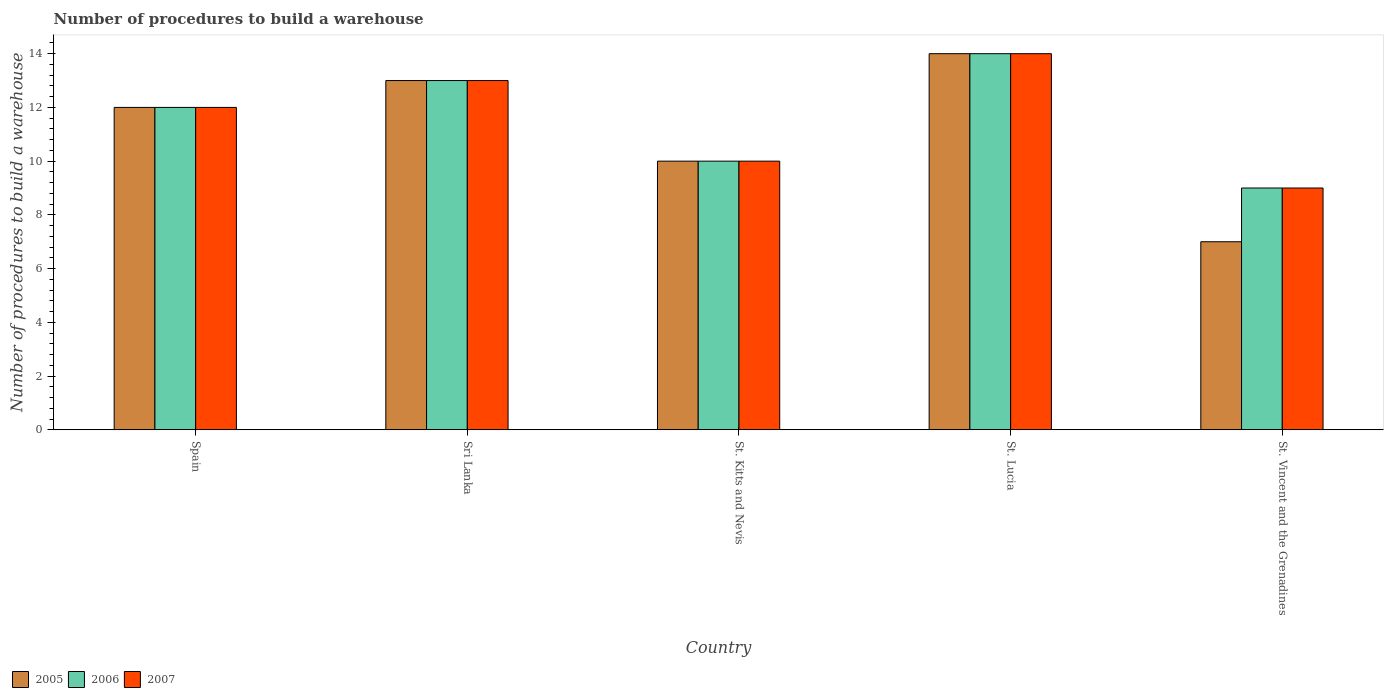How many different coloured bars are there?
Your answer should be compact. 3. Are the number of bars on each tick of the X-axis equal?
Give a very brief answer. Yes. How many bars are there on the 2nd tick from the left?
Offer a very short reply. 3. How many bars are there on the 4th tick from the right?
Make the answer very short. 3. What is the label of the 4th group of bars from the left?
Ensure brevity in your answer.  St. Lucia. In how many cases, is the number of bars for a given country not equal to the number of legend labels?
Ensure brevity in your answer.  0. Across all countries, what is the maximum number of procedures to build a warehouse in in 2006?
Your answer should be very brief. 14. In which country was the number of procedures to build a warehouse in in 2007 maximum?
Provide a succinct answer. St. Lucia. In which country was the number of procedures to build a warehouse in in 2005 minimum?
Provide a succinct answer. St. Vincent and the Grenadines. What is the total number of procedures to build a warehouse in in 2006 in the graph?
Give a very brief answer. 58. What is the difference between the number of procedures to build a warehouse in of/in 2006 and number of procedures to build a warehouse in of/in 2005 in Spain?
Keep it short and to the point. 0. What is the ratio of the number of procedures to build a warehouse in in 2007 in St. Kitts and Nevis to that in St. Lucia?
Offer a very short reply. 0.71. Is the number of procedures to build a warehouse in in 2006 in Spain less than that in Sri Lanka?
Provide a succinct answer. Yes. Is the difference between the number of procedures to build a warehouse in in 2006 in Spain and Sri Lanka greater than the difference between the number of procedures to build a warehouse in in 2005 in Spain and Sri Lanka?
Provide a succinct answer. No. In how many countries, is the number of procedures to build a warehouse in in 2007 greater than the average number of procedures to build a warehouse in in 2007 taken over all countries?
Provide a short and direct response. 3. Is it the case that in every country, the sum of the number of procedures to build a warehouse in in 2005 and number of procedures to build a warehouse in in 2006 is greater than the number of procedures to build a warehouse in in 2007?
Give a very brief answer. Yes. How many bars are there?
Offer a terse response. 15. Are all the bars in the graph horizontal?
Keep it short and to the point. No. How many countries are there in the graph?
Give a very brief answer. 5. Are the values on the major ticks of Y-axis written in scientific E-notation?
Your answer should be compact. No. Where does the legend appear in the graph?
Keep it short and to the point. Bottom left. How are the legend labels stacked?
Ensure brevity in your answer.  Horizontal. What is the title of the graph?
Your response must be concise. Number of procedures to build a warehouse. What is the label or title of the Y-axis?
Keep it short and to the point. Number of procedures to build a warehouse. What is the Number of procedures to build a warehouse in 2007 in Spain?
Give a very brief answer. 12. What is the Number of procedures to build a warehouse of 2005 in Sri Lanka?
Keep it short and to the point. 13. What is the Number of procedures to build a warehouse of 2006 in Sri Lanka?
Provide a succinct answer. 13. What is the Number of procedures to build a warehouse in 2005 in St. Kitts and Nevis?
Provide a succinct answer. 10. What is the Number of procedures to build a warehouse in 2007 in St. Kitts and Nevis?
Make the answer very short. 10. What is the Number of procedures to build a warehouse in 2005 in St. Vincent and the Grenadines?
Make the answer very short. 7. Across all countries, what is the maximum Number of procedures to build a warehouse of 2007?
Your answer should be very brief. 14. Across all countries, what is the minimum Number of procedures to build a warehouse in 2007?
Your answer should be compact. 9. What is the difference between the Number of procedures to build a warehouse of 2005 in Spain and that in Sri Lanka?
Your answer should be very brief. -1. What is the difference between the Number of procedures to build a warehouse of 2007 in Spain and that in Sri Lanka?
Give a very brief answer. -1. What is the difference between the Number of procedures to build a warehouse of 2005 in Spain and that in St. Kitts and Nevis?
Ensure brevity in your answer.  2. What is the difference between the Number of procedures to build a warehouse of 2005 in Spain and that in St. Lucia?
Make the answer very short. -2. What is the difference between the Number of procedures to build a warehouse of 2007 in Spain and that in St. Lucia?
Provide a succinct answer. -2. What is the difference between the Number of procedures to build a warehouse of 2005 in Spain and that in St. Vincent and the Grenadines?
Ensure brevity in your answer.  5. What is the difference between the Number of procedures to build a warehouse in 2006 in Spain and that in St. Vincent and the Grenadines?
Offer a very short reply. 3. What is the difference between the Number of procedures to build a warehouse of 2007 in Spain and that in St. Vincent and the Grenadines?
Provide a short and direct response. 3. What is the difference between the Number of procedures to build a warehouse in 2005 in Sri Lanka and that in St. Vincent and the Grenadines?
Ensure brevity in your answer.  6. What is the difference between the Number of procedures to build a warehouse of 2006 in Sri Lanka and that in St. Vincent and the Grenadines?
Your answer should be very brief. 4. What is the difference between the Number of procedures to build a warehouse of 2007 in Sri Lanka and that in St. Vincent and the Grenadines?
Keep it short and to the point. 4. What is the difference between the Number of procedures to build a warehouse in 2005 in St. Kitts and Nevis and that in St. Lucia?
Your answer should be compact. -4. What is the difference between the Number of procedures to build a warehouse in 2006 in St. Kitts and Nevis and that in St. Lucia?
Make the answer very short. -4. What is the difference between the Number of procedures to build a warehouse of 2005 in St. Kitts and Nevis and that in St. Vincent and the Grenadines?
Make the answer very short. 3. What is the difference between the Number of procedures to build a warehouse of 2006 in St. Kitts and Nevis and that in St. Vincent and the Grenadines?
Your response must be concise. 1. What is the difference between the Number of procedures to build a warehouse in 2007 in St. Kitts and Nevis and that in St. Vincent and the Grenadines?
Keep it short and to the point. 1. What is the difference between the Number of procedures to build a warehouse in 2006 in St. Lucia and that in St. Vincent and the Grenadines?
Give a very brief answer. 5. What is the difference between the Number of procedures to build a warehouse of 2005 in Spain and the Number of procedures to build a warehouse of 2006 in Sri Lanka?
Give a very brief answer. -1. What is the difference between the Number of procedures to build a warehouse of 2005 in Spain and the Number of procedures to build a warehouse of 2006 in St. Kitts and Nevis?
Keep it short and to the point. 2. What is the difference between the Number of procedures to build a warehouse in 2006 in Spain and the Number of procedures to build a warehouse in 2007 in St. Kitts and Nevis?
Keep it short and to the point. 2. What is the difference between the Number of procedures to build a warehouse in 2005 in Spain and the Number of procedures to build a warehouse in 2006 in St. Vincent and the Grenadines?
Ensure brevity in your answer.  3. What is the difference between the Number of procedures to build a warehouse in 2005 in Spain and the Number of procedures to build a warehouse in 2007 in St. Vincent and the Grenadines?
Your response must be concise. 3. What is the difference between the Number of procedures to build a warehouse of 2006 in Sri Lanka and the Number of procedures to build a warehouse of 2007 in St. Kitts and Nevis?
Ensure brevity in your answer.  3. What is the difference between the Number of procedures to build a warehouse of 2006 in Sri Lanka and the Number of procedures to build a warehouse of 2007 in St. Lucia?
Give a very brief answer. -1. What is the difference between the Number of procedures to build a warehouse in 2005 in Sri Lanka and the Number of procedures to build a warehouse in 2007 in St. Vincent and the Grenadines?
Your answer should be compact. 4. What is the difference between the Number of procedures to build a warehouse of 2005 in St. Kitts and Nevis and the Number of procedures to build a warehouse of 2006 in St. Lucia?
Your response must be concise. -4. What is the difference between the Number of procedures to build a warehouse in 2006 in St. Kitts and Nevis and the Number of procedures to build a warehouse in 2007 in St. Lucia?
Your response must be concise. -4. What is the difference between the Number of procedures to build a warehouse in 2006 in St. Kitts and Nevis and the Number of procedures to build a warehouse in 2007 in St. Vincent and the Grenadines?
Provide a succinct answer. 1. What is the difference between the Number of procedures to build a warehouse of 2005 in St. Lucia and the Number of procedures to build a warehouse of 2006 in St. Vincent and the Grenadines?
Make the answer very short. 5. What is the difference between the Number of procedures to build a warehouse of 2006 in St. Lucia and the Number of procedures to build a warehouse of 2007 in St. Vincent and the Grenadines?
Your response must be concise. 5. What is the average Number of procedures to build a warehouse in 2007 per country?
Your response must be concise. 11.6. What is the difference between the Number of procedures to build a warehouse of 2005 and Number of procedures to build a warehouse of 2006 in Spain?
Give a very brief answer. 0. What is the difference between the Number of procedures to build a warehouse in 2006 and Number of procedures to build a warehouse in 2007 in Spain?
Your answer should be compact. 0. What is the difference between the Number of procedures to build a warehouse of 2005 and Number of procedures to build a warehouse of 2006 in Sri Lanka?
Offer a very short reply. 0. What is the difference between the Number of procedures to build a warehouse of 2005 and Number of procedures to build a warehouse of 2007 in Sri Lanka?
Keep it short and to the point. 0. What is the difference between the Number of procedures to build a warehouse of 2006 and Number of procedures to build a warehouse of 2007 in Sri Lanka?
Your response must be concise. 0. What is the difference between the Number of procedures to build a warehouse in 2005 and Number of procedures to build a warehouse in 2006 in St. Lucia?
Offer a terse response. 0. What is the difference between the Number of procedures to build a warehouse in 2005 and Number of procedures to build a warehouse in 2007 in St. Lucia?
Keep it short and to the point. 0. What is the difference between the Number of procedures to build a warehouse of 2005 and Number of procedures to build a warehouse of 2006 in St. Vincent and the Grenadines?
Offer a very short reply. -2. What is the difference between the Number of procedures to build a warehouse in 2005 and Number of procedures to build a warehouse in 2007 in St. Vincent and the Grenadines?
Your response must be concise. -2. What is the ratio of the Number of procedures to build a warehouse of 2005 in Spain to that in Sri Lanka?
Provide a succinct answer. 0.92. What is the ratio of the Number of procedures to build a warehouse of 2006 in Spain to that in Sri Lanka?
Offer a terse response. 0.92. What is the ratio of the Number of procedures to build a warehouse of 2007 in Spain to that in Sri Lanka?
Keep it short and to the point. 0.92. What is the ratio of the Number of procedures to build a warehouse in 2005 in Spain to that in St. Kitts and Nevis?
Your response must be concise. 1.2. What is the ratio of the Number of procedures to build a warehouse in 2006 in Spain to that in St. Kitts and Nevis?
Offer a terse response. 1.2. What is the ratio of the Number of procedures to build a warehouse of 2006 in Spain to that in St. Lucia?
Offer a terse response. 0.86. What is the ratio of the Number of procedures to build a warehouse of 2005 in Spain to that in St. Vincent and the Grenadines?
Make the answer very short. 1.71. What is the ratio of the Number of procedures to build a warehouse in 2007 in Spain to that in St. Vincent and the Grenadines?
Give a very brief answer. 1.33. What is the ratio of the Number of procedures to build a warehouse of 2005 in Sri Lanka to that in St. Kitts and Nevis?
Keep it short and to the point. 1.3. What is the ratio of the Number of procedures to build a warehouse in 2007 in Sri Lanka to that in St. Kitts and Nevis?
Your answer should be compact. 1.3. What is the ratio of the Number of procedures to build a warehouse in 2005 in Sri Lanka to that in St. Lucia?
Your response must be concise. 0.93. What is the ratio of the Number of procedures to build a warehouse in 2005 in Sri Lanka to that in St. Vincent and the Grenadines?
Provide a succinct answer. 1.86. What is the ratio of the Number of procedures to build a warehouse of 2006 in Sri Lanka to that in St. Vincent and the Grenadines?
Your response must be concise. 1.44. What is the ratio of the Number of procedures to build a warehouse of 2007 in Sri Lanka to that in St. Vincent and the Grenadines?
Provide a short and direct response. 1.44. What is the ratio of the Number of procedures to build a warehouse of 2005 in St. Kitts and Nevis to that in St. Vincent and the Grenadines?
Your response must be concise. 1.43. What is the ratio of the Number of procedures to build a warehouse in 2006 in St. Kitts and Nevis to that in St. Vincent and the Grenadines?
Your response must be concise. 1.11. What is the ratio of the Number of procedures to build a warehouse in 2007 in St. Kitts and Nevis to that in St. Vincent and the Grenadines?
Offer a terse response. 1.11. What is the ratio of the Number of procedures to build a warehouse in 2005 in St. Lucia to that in St. Vincent and the Grenadines?
Your answer should be very brief. 2. What is the ratio of the Number of procedures to build a warehouse of 2006 in St. Lucia to that in St. Vincent and the Grenadines?
Give a very brief answer. 1.56. What is the ratio of the Number of procedures to build a warehouse in 2007 in St. Lucia to that in St. Vincent and the Grenadines?
Your answer should be very brief. 1.56. What is the difference between the highest and the second highest Number of procedures to build a warehouse of 2005?
Your response must be concise. 1. What is the difference between the highest and the second highest Number of procedures to build a warehouse of 2007?
Make the answer very short. 1. What is the difference between the highest and the lowest Number of procedures to build a warehouse in 2005?
Your response must be concise. 7. What is the difference between the highest and the lowest Number of procedures to build a warehouse in 2006?
Your answer should be compact. 5. 